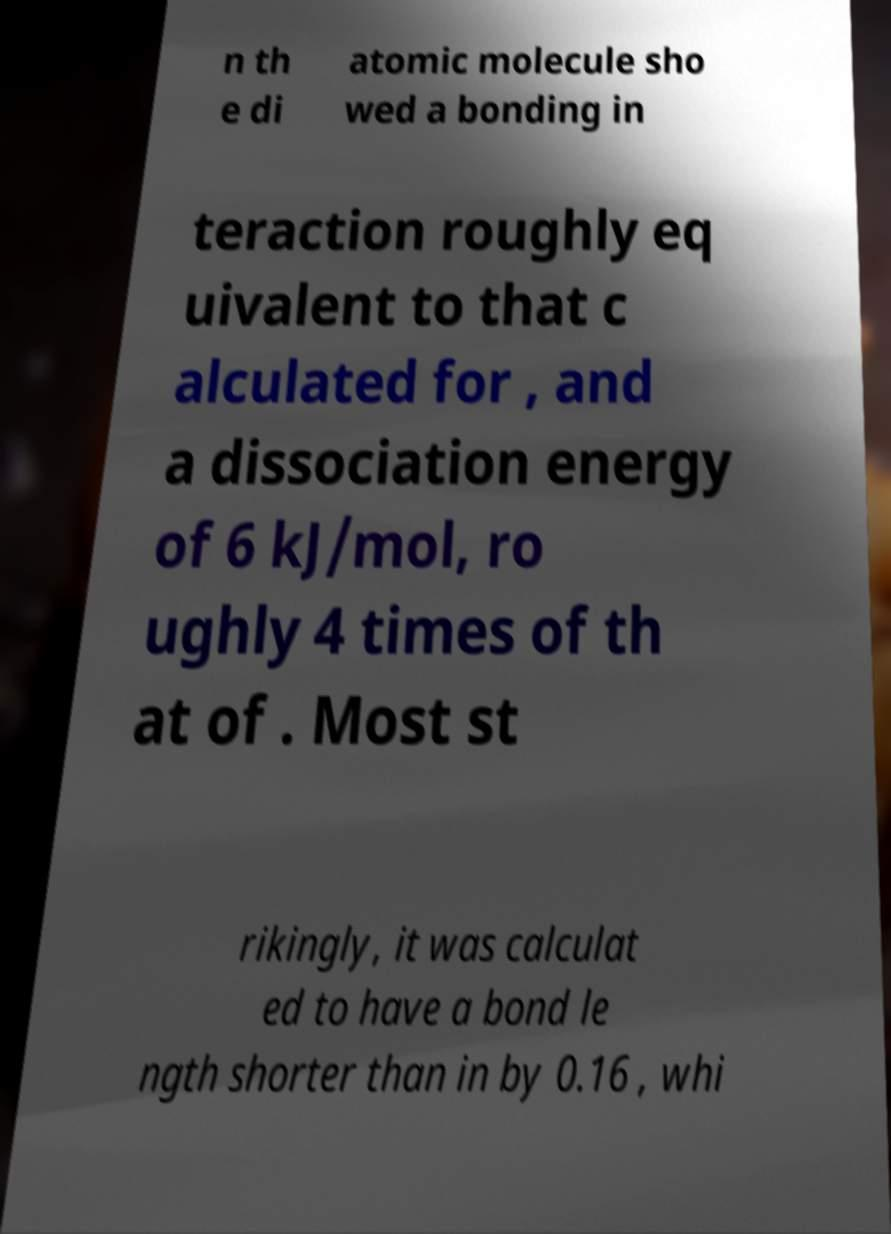Could you assist in decoding the text presented in this image and type it out clearly? n th e di atomic molecule sho wed a bonding in teraction roughly eq uivalent to that c alculated for , and a dissociation energy of 6 kJ/mol, ro ughly 4 times of th at of . Most st rikingly, it was calculat ed to have a bond le ngth shorter than in by 0.16 , whi 